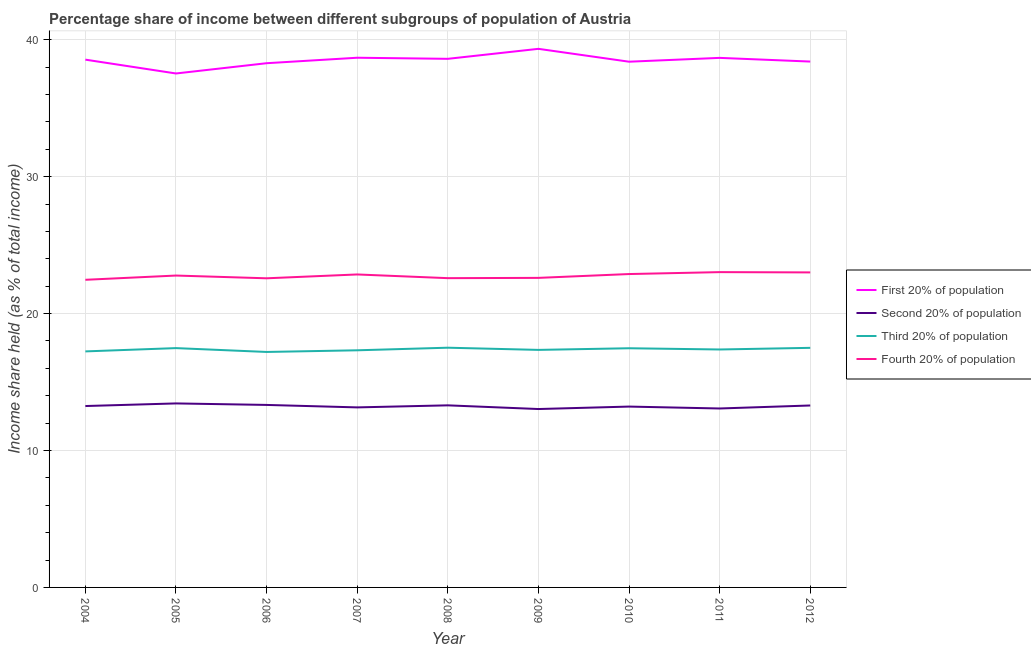Does the line corresponding to share of the income held by fourth 20% of the population intersect with the line corresponding to share of the income held by second 20% of the population?
Offer a very short reply. No. Is the number of lines equal to the number of legend labels?
Offer a very short reply. Yes. What is the share of the income held by first 20% of the population in 2011?
Your response must be concise. 38.68. Across all years, what is the maximum share of the income held by first 20% of the population?
Offer a very short reply. 39.34. In which year was the share of the income held by third 20% of the population maximum?
Offer a terse response. 2008. What is the total share of the income held by fourth 20% of the population in the graph?
Make the answer very short. 204.82. What is the difference between the share of the income held by fourth 20% of the population in 2007 and that in 2008?
Your answer should be compact. 0.27. What is the difference between the share of the income held by third 20% of the population in 2004 and the share of the income held by second 20% of the population in 2005?
Provide a succinct answer. 3.8. What is the average share of the income held by third 20% of the population per year?
Provide a succinct answer. 17.38. In the year 2007, what is the difference between the share of the income held by second 20% of the population and share of the income held by fourth 20% of the population?
Provide a short and direct response. -9.71. In how many years, is the share of the income held by first 20% of the population greater than 22 %?
Your response must be concise. 9. What is the ratio of the share of the income held by second 20% of the population in 2005 to that in 2007?
Keep it short and to the point. 1.02. Is the difference between the share of the income held by first 20% of the population in 2004 and 2005 greater than the difference between the share of the income held by third 20% of the population in 2004 and 2005?
Ensure brevity in your answer.  Yes. What is the difference between the highest and the second highest share of the income held by fourth 20% of the population?
Your answer should be very brief. 0.02. What is the difference between the highest and the lowest share of the income held by fourth 20% of the population?
Your answer should be compact. 0.56. Is the sum of the share of the income held by second 20% of the population in 2005 and 2008 greater than the maximum share of the income held by first 20% of the population across all years?
Offer a terse response. No. Is it the case that in every year, the sum of the share of the income held by first 20% of the population and share of the income held by second 20% of the population is greater than the sum of share of the income held by fourth 20% of the population and share of the income held by third 20% of the population?
Your response must be concise. Yes. Is it the case that in every year, the sum of the share of the income held by first 20% of the population and share of the income held by second 20% of the population is greater than the share of the income held by third 20% of the population?
Provide a short and direct response. Yes. Does the share of the income held by second 20% of the population monotonically increase over the years?
Make the answer very short. No. Is the share of the income held by second 20% of the population strictly greater than the share of the income held by third 20% of the population over the years?
Offer a terse response. No. What is the title of the graph?
Offer a terse response. Percentage share of income between different subgroups of population of Austria. Does "Quality Certification" appear as one of the legend labels in the graph?
Your answer should be compact. No. What is the label or title of the X-axis?
Make the answer very short. Year. What is the label or title of the Y-axis?
Your answer should be compact. Income share held (as % of total income). What is the Income share held (as % of total income) of First 20% of population in 2004?
Offer a very short reply. 38.55. What is the Income share held (as % of total income) of Second 20% of population in 2004?
Your answer should be compact. 13.25. What is the Income share held (as % of total income) of Third 20% of population in 2004?
Ensure brevity in your answer.  17.24. What is the Income share held (as % of total income) of Fourth 20% of population in 2004?
Offer a very short reply. 22.47. What is the Income share held (as % of total income) of First 20% of population in 2005?
Your answer should be very brief. 37.54. What is the Income share held (as % of total income) of Second 20% of population in 2005?
Your answer should be very brief. 13.44. What is the Income share held (as % of total income) of Third 20% of population in 2005?
Your answer should be very brief. 17.48. What is the Income share held (as % of total income) of Fourth 20% of population in 2005?
Offer a very short reply. 22.78. What is the Income share held (as % of total income) of First 20% of population in 2006?
Your answer should be compact. 38.29. What is the Income share held (as % of total income) in Second 20% of population in 2006?
Keep it short and to the point. 13.33. What is the Income share held (as % of total income) in Third 20% of population in 2006?
Your answer should be very brief. 17.2. What is the Income share held (as % of total income) of Fourth 20% of population in 2006?
Your response must be concise. 22.58. What is the Income share held (as % of total income) in First 20% of population in 2007?
Your answer should be very brief. 38.69. What is the Income share held (as % of total income) in Second 20% of population in 2007?
Your answer should be compact. 13.15. What is the Income share held (as % of total income) of Third 20% of population in 2007?
Give a very brief answer. 17.32. What is the Income share held (as % of total income) in Fourth 20% of population in 2007?
Provide a short and direct response. 22.86. What is the Income share held (as % of total income) of First 20% of population in 2008?
Your answer should be compact. 38.61. What is the Income share held (as % of total income) in Third 20% of population in 2008?
Your answer should be very brief. 17.51. What is the Income share held (as % of total income) in Fourth 20% of population in 2008?
Your answer should be very brief. 22.59. What is the Income share held (as % of total income) in First 20% of population in 2009?
Keep it short and to the point. 39.34. What is the Income share held (as % of total income) in Second 20% of population in 2009?
Ensure brevity in your answer.  13.03. What is the Income share held (as % of total income) of Third 20% of population in 2009?
Your response must be concise. 17.35. What is the Income share held (as % of total income) in Fourth 20% of population in 2009?
Give a very brief answer. 22.61. What is the Income share held (as % of total income) of First 20% of population in 2010?
Your answer should be compact. 38.4. What is the Income share held (as % of total income) in Second 20% of population in 2010?
Your response must be concise. 13.21. What is the Income share held (as % of total income) in Third 20% of population in 2010?
Ensure brevity in your answer.  17.47. What is the Income share held (as % of total income) in Fourth 20% of population in 2010?
Give a very brief answer. 22.89. What is the Income share held (as % of total income) in First 20% of population in 2011?
Your answer should be compact. 38.68. What is the Income share held (as % of total income) of Second 20% of population in 2011?
Your answer should be very brief. 13.07. What is the Income share held (as % of total income) in Third 20% of population in 2011?
Keep it short and to the point. 17.38. What is the Income share held (as % of total income) in Fourth 20% of population in 2011?
Your answer should be compact. 23.03. What is the Income share held (as % of total income) in First 20% of population in 2012?
Ensure brevity in your answer.  38.41. What is the Income share held (as % of total income) in Second 20% of population in 2012?
Give a very brief answer. 13.29. What is the Income share held (as % of total income) in Fourth 20% of population in 2012?
Your answer should be very brief. 23.01. Across all years, what is the maximum Income share held (as % of total income) in First 20% of population?
Ensure brevity in your answer.  39.34. Across all years, what is the maximum Income share held (as % of total income) in Second 20% of population?
Provide a succinct answer. 13.44. Across all years, what is the maximum Income share held (as % of total income) of Third 20% of population?
Provide a succinct answer. 17.51. Across all years, what is the maximum Income share held (as % of total income) in Fourth 20% of population?
Provide a short and direct response. 23.03. Across all years, what is the minimum Income share held (as % of total income) in First 20% of population?
Your answer should be compact. 37.54. Across all years, what is the minimum Income share held (as % of total income) in Second 20% of population?
Make the answer very short. 13.03. Across all years, what is the minimum Income share held (as % of total income) of Fourth 20% of population?
Your response must be concise. 22.47. What is the total Income share held (as % of total income) of First 20% of population in the graph?
Your answer should be very brief. 346.51. What is the total Income share held (as % of total income) in Second 20% of population in the graph?
Give a very brief answer. 119.07. What is the total Income share held (as % of total income) of Third 20% of population in the graph?
Provide a succinct answer. 156.45. What is the total Income share held (as % of total income) in Fourth 20% of population in the graph?
Give a very brief answer. 204.82. What is the difference between the Income share held (as % of total income) in First 20% of population in 2004 and that in 2005?
Provide a succinct answer. 1.01. What is the difference between the Income share held (as % of total income) in Second 20% of population in 2004 and that in 2005?
Give a very brief answer. -0.19. What is the difference between the Income share held (as % of total income) of Third 20% of population in 2004 and that in 2005?
Offer a terse response. -0.24. What is the difference between the Income share held (as % of total income) in Fourth 20% of population in 2004 and that in 2005?
Your answer should be compact. -0.31. What is the difference between the Income share held (as % of total income) of First 20% of population in 2004 and that in 2006?
Ensure brevity in your answer.  0.26. What is the difference between the Income share held (as % of total income) in Second 20% of population in 2004 and that in 2006?
Provide a succinct answer. -0.08. What is the difference between the Income share held (as % of total income) of Third 20% of population in 2004 and that in 2006?
Make the answer very short. 0.04. What is the difference between the Income share held (as % of total income) of Fourth 20% of population in 2004 and that in 2006?
Keep it short and to the point. -0.11. What is the difference between the Income share held (as % of total income) of First 20% of population in 2004 and that in 2007?
Your answer should be very brief. -0.14. What is the difference between the Income share held (as % of total income) in Second 20% of population in 2004 and that in 2007?
Provide a short and direct response. 0.1. What is the difference between the Income share held (as % of total income) of Third 20% of population in 2004 and that in 2007?
Keep it short and to the point. -0.08. What is the difference between the Income share held (as % of total income) of Fourth 20% of population in 2004 and that in 2007?
Keep it short and to the point. -0.39. What is the difference between the Income share held (as % of total income) of First 20% of population in 2004 and that in 2008?
Keep it short and to the point. -0.06. What is the difference between the Income share held (as % of total income) in Third 20% of population in 2004 and that in 2008?
Give a very brief answer. -0.27. What is the difference between the Income share held (as % of total income) of Fourth 20% of population in 2004 and that in 2008?
Keep it short and to the point. -0.12. What is the difference between the Income share held (as % of total income) in First 20% of population in 2004 and that in 2009?
Your response must be concise. -0.79. What is the difference between the Income share held (as % of total income) in Second 20% of population in 2004 and that in 2009?
Make the answer very short. 0.22. What is the difference between the Income share held (as % of total income) of Third 20% of population in 2004 and that in 2009?
Provide a succinct answer. -0.11. What is the difference between the Income share held (as % of total income) of Fourth 20% of population in 2004 and that in 2009?
Your answer should be compact. -0.14. What is the difference between the Income share held (as % of total income) of First 20% of population in 2004 and that in 2010?
Offer a very short reply. 0.15. What is the difference between the Income share held (as % of total income) in Third 20% of population in 2004 and that in 2010?
Your response must be concise. -0.23. What is the difference between the Income share held (as % of total income) of Fourth 20% of population in 2004 and that in 2010?
Keep it short and to the point. -0.42. What is the difference between the Income share held (as % of total income) of First 20% of population in 2004 and that in 2011?
Keep it short and to the point. -0.13. What is the difference between the Income share held (as % of total income) of Second 20% of population in 2004 and that in 2011?
Offer a terse response. 0.18. What is the difference between the Income share held (as % of total income) in Third 20% of population in 2004 and that in 2011?
Give a very brief answer. -0.14. What is the difference between the Income share held (as % of total income) of Fourth 20% of population in 2004 and that in 2011?
Keep it short and to the point. -0.56. What is the difference between the Income share held (as % of total income) of First 20% of population in 2004 and that in 2012?
Offer a very short reply. 0.14. What is the difference between the Income share held (as % of total income) in Second 20% of population in 2004 and that in 2012?
Provide a succinct answer. -0.04. What is the difference between the Income share held (as % of total income) in Third 20% of population in 2004 and that in 2012?
Give a very brief answer. -0.26. What is the difference between the Income share held (as % of total income) in Fourth 20% of population in 2004 and that in 2012?
Make the answer very short. -0.54. What is the difference between the Income share held (as % of total income) in First 20% of population in 2005 and that in 2006?
Your response must be concise. -0.75. What is the difference between the Income share held (as % of total income) in Second 20% of population in 2005 and that in 2006?
Keep it short and to the point. 0.11. What is the difference between the Income share held (as % of total income) in Third 20% of population in 2005 and that in 2006?
Offer a very short reply. 0.28. What is the difference between the Income share held (as % of total income) of First 20% of population in 2005 and that in 2007?
Keep it short and to the point. -1.15. What is the difference between the Income share held (as % of total income) of Second 20% of population in 2005 and that in 2007?
Provide a succinct answer. 0.29. What is the difference between the Income share held (as % of total income) in Third 20% of population in 2005 and that in 2007?
Your response must be concise. 0.16. What is the difference between the Income share held (as % of total income) of Fourth 20% of population in 2005 and that in 2007?
Provide a short and direct response. -0.08. What is the difference between the Income share held (as % of total income) in First 20% of population in 2005 and that in 2008?
Provide a succinct answer. -1.07. What is the difference between the Income share held (as % of total income) of Second 20% of population in 2005 and that in 2008?
Give a very brief answer. 0.14. What is the difference between the Income share held (as % of total income) of Third 20% of population in 2005 and that in 2008?
Give a very brief answer. -0.03. What is the difference between the Income share held (as % of total income) in Fourth 20% of population in 2005 and that in 2008?
Give a very brief answer. 0.19. What is the difference between the Income share held (as % of total income) in First 20% of population in 2005 and that in 2009?
Your answer should be very brief. -1.8. What is the difference between the Income share held (as % of total income) of Second 20% of population in 2005 and that in 2009?
Provide a short and direct response. 0.41. What is the difference between the Income share held (as % of total income) of Third 20% of population in 2005 and that in 2009?
Keep it short and to the point. 0.13. What is the difference between the Income share held (as % of total income) in Fourth 20% of population in 2005 and that in 2009?
Keep it short and to the point. 0.17. What is the difference between the Income share held (as % of total income) of First 20% of population in 2005 and that in 2010?
Your answer should be very brief. -0.86. What is the difference between the Income share held (as % of total income) in Second 20% of population in 2005 and that in 2010?
Keep it short and to the point. 0.23. What is the difference between the Income share held (as % of total income) in Third 20% of population in 2005 and that in 2010?
Keep it short and to the point. 0.01. What is the difference between the Income share held (as % of total income) of Fourth 20% of population in 2005 and that in 2010?
Provide a succinct answer. -0.11. What is the difference between the Income share held (as % of total income) of First 20% of population in 2005 and that in 2011?
Your answer should be very brief. -1.14. What is the difference between the Income share held (as % of total income) of Second 20% of population in 2005 and that in 2011?
Provide a succinct answer. 0.37. What is the difference between the Income share held (as % of total income) of First 20% of population in 2005 and that in 2012?
Provide a succinct answer. -0.87. What is the difference between the Income share held (as % of total income) of Second 20% of population in 2005 and that in 2012?
Keep it short and to the point. 0.15. What is the difference between the Income share held (as % of total income) in Third 20% of population in 2005 and that in 2012?
Your response must be concise. -0.02. What is the difference between the Income share held (as % of total income) in Fourth 20% of population in 2005 and that in 2012?
Offer a terse response. -0.23. What is the difference between the Income share held (as % of total income) of Second 20% of population in 2006 and that in 2007?
Provide a short and direct response. 0.18. What is the difference between the Income share held (as % of total income) in Third 20% of population in 2006 and that in 2007?
Provide a succinct answer. -0.12. What is the difference between the Income share held (as % of total income) of Fourth 20% of population in 2006 and that in 2007?
Make the answer very short. -0.28. What is the difference between the Income share held (as % of total income) of First 20% of population in 2006 and that in 2008?
Your answer should be very brief. -0.32. What is the difference between the Income share held (as % of total income) in Third 20% of population in 2006 and that in 2008?
Provide a succinct answer. -0.31. What is the difference between the Income share held (as % of total income) in Fourth 20% of population in 2006 and that in 2008?
Keep it short and to the point. -0.01. What is the difference between the Income share held (as % of total income) of First 20% of population in 2006 and that in 2009?
Your response must be concise. -1.05. What is the difference between the Income share held (as % of total income) in Third 20% of population in 2006 and that in 2009?
Ensure brevity in your answer.  -0.15. What is the difference between the Income share held (as % of total income) in Fourth 20% of population in 2006 and that in 2009?
Provide a short and direct response. -0.03. What is the difference between the Income share held (as % of total income) of First 20% of population in 2006 and that in 2010?
Offer a very short reply. -0.11. What is the difference between the Income share held (as % of total income) of Second 20% of population in 2006 and that in 2010?
Give a very brief answer. 0.12. What is the difference between the Income share held (as % of total income) of Third 20% of population in 2006 and that in 2010?
Provide a succinct answer. -0.27. What is the difference between the Income share held (as % of total income) of Fourth 20% of population in 2006 and that in 2010?
Make the answer very short. -0.31. What is the difference between the Income share held (as % of total income) of First 20% of population in 2006 and that in 2011?
Keep it short and to the point. -0.39. What is the difference between the Income share held (as % of total income) in Second 20% of population in 2006 and that in 2011?
Offer a terse response. 0.26. What is the difference between the Income share held (as % of total income) in Third 20% of population in 2006 and that in 2011?
Offer a very short reply. -0.18. What is the difference between the Income share held (as % of total income) of Fourth 20% of population in 2006 and that in 2011?
Your answer should be very brief. -0.45. What is the difference between the Income share held (as % of total income) in First 20% of population in 2006 and that in 2012?
Your answer should be compact. -0.12. What is the difference between the Income share held (as % of total income) in Second 20% of population in 2006 and that in 2012?
Offer a very short reply. 0.04. What is the difference between the Income share held (as % of total income) of Fourth 20% of population in 2006 and that in 2012?
Make the answer very short. -0.43. What is the difference between the Income share held (as % of total income) in First 20% of population in 2007 and that in 2008?
Provide a succinct answer. 0.08. What is the difference between the Income share held (as % of total income) in Third 20% of population in 2007 and that in 2008?
Your answer should be very brief. -0.19. What is the difference between the Income share held (as % of total income) of Fourth 20% of population in 2007 and that in 2008?
Your answer should be very brief. 0.27. What is the difference between the Income share held (as % of total income) in First 20% of population in 2007 and that in 2009?
Keep it short and to the point. -0.65. What is the difference between the Income share held (as % of total income) in Second 20% of population in 2007 and that in 2009?
Provide a short and direct response. 0.12. What is the difference between the Income share held (as % of total income) in Third 20% of population in 2007 and that in 2009?
Ensure brevity in your answer.  -0.03. What is the difference between the Income share held (as % of total income) of Fourth 20% of population in 2007 and that in 2009?
Your answer should be very brief. 0.25. What is the difference between the Income share held (as % of total income) of First 20% of population in 2007 and that in 2010?
Make the answer very short. 0.29. What is the difference between the Income share held (as % of total income) of Second 20% of population in 2007 and that in 2010?
Your response must be concise. -0.06. What is the difference between the Income share held (as % of total income) of Fourth 20% of population in 2007 and that in 2010?
Make the answer very short. -0.03. What is the difference between the Income share held (as % of total income) in First 20% of population in 2007 and that in 2011?
Your answer should be compact. 0.01. What is the difference between the Income share held (as % of total income) in Second 20% of population in 2007 and that in 2011?
Your answer should be very brief. 0.08. What is the difference between the Income share held (as % of total income) in Third 20% of population in 2007 and that in 2011?
Your answer should be very brief. -0.06. What is the difference between the Income share held (as % of total income) in Fourth 20% of population in 2007 and that in 2011?
Offer a terse response. -0.17. What is the difference between the Income share held (as % of total income) of First 20% of population in 2007 and that in 2012?
Your answer should be very brief. 0.28. What is the difference between the Income share held (as % of total income) in Second 20% of population in 2007 and that in 2012?
Your response must be concise. -0.14. What is the difference between the Income share held (as % of total income) in Third 20% of population in 2007 and that in 2012?
Your answer should be very brief. -0.18. What is the difference between the Income share held (as % of total income) of Fourth 20% of population in 2007 and that in 2012?
Give a very brief answer. -0.15. What is the difference between the Income share held (as % of total income) in First 20% of population in 2008 and that in 2009?
Provide a short and direct response. -0.73. What is the difference between the Income share held (as % of total income) of Second 20% of population in 2008 and that in 2009?
Ensure brevity in your answer.  0.27. What is the difference between the Income share held (as % of total income) of Third 20% of population in 2008 and that in 2009?
Make the answer very short. 0.16. What is the difference between the Income share held (as % of total income) in Fourth 20% of population in 2008 and that in 2009?
Keep it short and to the point. -0.02. What is the difference between the Income share held (as % of total income) in First 20% of population in 2008 and that in 2010?
Keep it short and to the point. 0.21. What is the difference between the Income share held (as % of total income) of Second 20% of population in 2008 and that in 2010?
Provide a short and direct response. 0.09. What is the difference between the Income share held (as % of total income) in Third 20% of population in 2008 and that in 2010?
Ensure brevity in your answer.  0.04. What is the difference between the Income share held (as % of total income) of First 20% of population in 2008 and that in 2011?
Provide a short and direct response. -0.07. What is the difference between the Income share held (as % of total income) in Second 20% of population in 2008 and that in 2011?
Offer a terse response. 0.23. What is the difference between the Income share held (as % of total income) of Third 20% of population in 2008 and that in 2011?
Provide a short and direct response. 0.13. What is the difference between the Income share held (as % of total income) of Fourth 20% of population in 2008 and that in 2011?
Keep it short and to the point. -0.44. What is the difference between the Income share held (as % of total income) of First 20% of population in 2008 and that in 2012?
Ensure brevity in your answer.  0.2. What is the difference between the Income share held (as % of total income) in Second 20% of population in 2008 and that in 2012?
Your answer should be compact. 0.01. What is the difference between the Income share held (as % of total income) in Fourth 20% of population in 2008 and that in 2012?
Your answer should be compact. -0.42. What is the difference between the Income share held (as % of total income) in First 20% of population in 2009 and that in 2010?
Provide a succinct answer. 0.94. What is the difference between the Income share held (as % of total income) in Second 20% of population in 2009 and that in 2010?
Your answer should be compact. -0.18. What is the difference between the Income share held (as % of total income) in Third 20% of population in 2009 and that in 2010?
Keep it short and to the point. -0.12. What is the difference between the Income share held (as % of total income) in Fourth 20% of population in 2009 and that in 2010?
Provide a succinct answer. -0.28. What is the difference between the Income share held (as % of total income) of First 20% of population in 2009 and that in 2011?
Your response must be concise. 0.66. What is the difference between the Income share held (as % of total income) in Second 20% of population in 2009 and that in 2011?
Your answer should be compact. -0.04. What is the difference between the Income share held (as % of total income) of Third 20% of population in 2009 and that in 2011?
Make the answer very short. -0.03. What is the difference between the Income share held (as % of total income) in Fourth 20% of population in 2009 and that in 2011?
Provide a succinct answer. -0.42. What is the difference between the Income share held (as % of total income) in Second 20% of population in 2009 and that in 2012?
Your response must be concise. -0.26. What is the difference between the Income share held (as % of total income) in First 20% of population in 2010 and that in 2011?
Your answer should be compact. -0.28. What is the difference between the Income share held (as % of total income) of Second 20% of population in 2010 and that in 2011?
Make the answer very short. 0.14. What is the difference between the Income share held (as % of total income) of Third 20% of population in 2010 and that in 2011?
Your answer should be very brief. 0.09. What is the difference between the Income share held (as % of total income) of Fourth 20% of population in 2010 and that in 2011?
Your answer should be very brief. -0.14. What is the difference between the Income share held (as % of total income) in First 20% of population in 2010 and that in 2012?
Offer a very short reply. -0.01. What is the difference between the Income share held (as % of total income) in Second 20% of population in 2010 and that in 2012?
Give a very brief answer. -0.08. What is the difference between the Income share held (as % of total income) in Third 20% of population in 2010 and that in 2012?
Keep it short and to the point. -0.03. What is the difference between the Income share held (as % of total income) in Fourth 20% of population in 2010 and that in 2012?
Your answer should be compact. -0.12. What is the difference between the Income share held (as % of total income) of First 20% of population in 2011 and that in 2012?
Provide a short and direct response. 0.27. What is the difference between the Income share held (as % of total income) of Second 20% of population in 2011 and that in 2012?
Your answer should be compact. -0.22. What is the difference between the Income share held (as % of total income) in Third 20% of population in 2011 and that in 2012?
Keep it short and to the point. -0.12. What is the difference between the Income share held (as % of total income) of First 20% of population in 2004 and the Income share held (as % of total income) of Second 20% of population in 2005?
Ensure brevity in your answer.  25.11. What is the difference between the Income share held (as % of total income) of First 20% of population in 2004 and the Income share held (as % of total income) of Third 20% of population in 2005?
Provide a short and direct response. 21.07. What is the difference between the Income share held (as % of total income) in First 20% of population in 2004 and the Income share held (as % of total income) in Fourth 20% of population in 2005?
Your answer should be very brief. 15.77. What is the difference between the Income share held (as % of total income) in Second 20% of population in 2004 and the Income share held (as % of total income) in Third 20% of population in 2005?
Ensure brevity in your answer.  -4.23. What is the difference between the Income share held (as % of total income) in Second 20% of population in 2004 and the Income share held (as % of total income) in Fourth 20% of population in 2005?
Provide a succinct answer. -9.53. What is the difference between the Income share held (as % of total income) of Third 20% of population in 2004 and the Income share held (as % of total income) of Fourth 20% of population in 2005?
Ensure brevity in your answer.  -5.54. What is the difference between the Income share held (as % of total income) of First 20% of population in 2004 and the Income share held (as % of total income) of Second 20% of population in 2006?
Your response must be concise. 25.22. What is the difference between the Income share held (as % of total income) in First 20% of population in 2004 and the Income share held (as % of total income) in Third 20% of population in 2006?
Your response must be concise. 21.35. What is the difference between the Income share held (as % of total income) in First 20% of population in 2004 and the Income share held (as % of total income) in Fourth 20% of population in 2006?
Your response must be concise. 15.97. What is the difference between the Income share held (as % of total income) in Second 20% of population in 2004 and the Income share held (as % of total income) in Third 20% of population in 2006?
Keep it short and to the point. -3.95. What is the difference between the Income share held (as % of total income) of Second 20% of population in 2004 and the Income share held (as % of total income) of Fourth 20% of population in 2006?
Your answer should be compact. -9.33. What is the difference between the Income share held (as % of total income) in Third 20% of population in 2004 and the Income share held (as % of total income) in Fourth 20% of population in 2006?
Your answer should be very brief. -5.34. What is the difference between the Income share held (as % of total income) of First 20% of population in 2004 and the Income share held (as % of total income) of Second 20% of population in 2007?
Your response must be concise. 25.4. What is the difference between the Income share held (as % of total income) of First 20% of population in 2004 and the Income share held (as % of total income) of Third 20% of population in 2007?
Your answer should be very brief. 21.23. What is the difference between the Income share held (as % of total income) in First 20% of population in 2004 and the Income share held (as % of total income) in Fourth 20% of population in 2007?
Offer a terse response. 15.69. What is the difference between the Income share held (as % of total income) of Second 20% of population in 2004 and the Income share held (as % of total income) of Third 20% of population in 2007?
Your answer should be very brief. -4.07. What is the difference between the Income share held (as % of total income) in Second 20% of population in 2004 and the Income share held (as % of total income) in Fourth 20% of population in 2007?
Give a very brief answer. -9.61. What is the difference between the Income share held (as % of total income) of Third 20% of population in 2004 and the Income share held (as % of total income) of Fourth 20% of population in 2007?
Ensure brevity in your answer.  -5.62. What is the difference between the Income share held (as % of total income) of First 20% of population in 2004 and the Income share held (as % of total income) of Second 20% of population in 2008?
Make the answer very short. 25.25. What is the difference between the Income share held (as % of total income) of First 20% of population in 2004 and the Income share held (as % of total income) of Third 20% of population in 2008?
Your answer should be very brief. 21.04. What is the difference between the Income share held (as % of total income) in First 20% of population in 2004 and the Income share held (as % of total income) in Fourth 20% of population in 2008?
Your response must be concise. 15.96. What is the difference between the Income share held (as % of total income) of Second 20% of population in 2004 and the Income share held (as % of total income) of Third 20% of population in 2008?
Make the answer very short. -4.26. What is the difference between the Income share held (as % of total income) in Second 20% of population in 2004 and the Income share held (as % of total income) in Fourth 20% of population in 2008?
Your answer should be very brief. -9.34. What is the difference between the Income share held (as % of total income) in Third 20% of population in 2004 and the Income share held (as % of total income) in Fourth 20% of population in 2008?
Offer a very short reply. -5.35. What is the difference between the Income share held (as % of total income) of First 20% of population in 2004 and the Income share held (as % of total income) of Second 20% of population in 2009?
Your response must be concise. 25.52. What is the difference between the Income share held (as % of total income) of First 20% of population in 2004 and the Income share held (as % of total income) of Third 20% of population in 2009?
Offer a very short reply. 21.2. What is the difference between the Income share held (as % of total income) in First 20% of population in 2004 and the Income share held (as % of total income) in Fourth 20% of population in 2009?
Your answer should be compact. 15.94. What is the difference between the Income share held (as % of total income) in Second 20% of population in 2004 and the Income share held (as % of total income) in Fourth 20% of population in 2009?
Your response must be concise. -9.36. What is the difference between the Income share held (as % of total income) in Third 20% of population in 2004 and the Income share held (as % of total income) in Fourth 20% of population in 2009?
Offer a very short reply. -5.37. What is the difference between the Income share held (as % of total income) in First 20% of population in 2004 and the Income share held (as % of total income) in Second 20% of population in 2010?
Your answer should be compact. 25.34. What is the difference between the Income share held (as % of total income) of First 20% of population in 2004 and the Income share held (as % of total income) of Third 20% of population in 2010?
Offer a terse response. 21.08. What is the difference between the Income share held (as % of total income) of First 20% of population in 2004 and the Income share held (as % of total income) of Fourth 20% of population in 2010?
Provide a short and direct response. 15.66. What is the difference between the Income share held (as % of total income) of Second 20% of population in 2004 and the Income share held (as % of total income) of Third 20% of population in 2010?
Your answer should be very brief. -4.22. What is the difference between the Income share held (as % of total income) of Second 20% of population in 2004 and the Income share held (as % of total income) of Fourth 20% of population in 2010?
Provide a short and direct response. -9.64. What is the difference between the Income share held (as % of total income) of Third 20% of population in 2004 and the Income share held (as % of total income) of Fourth 20% of population in 2010?
Offer a very short reply. -5.65. What is the difference between the Income share held (as % of total income) in First 20% of population in 2004 and the Income share held (as % of total income) in Second 20% of population in 2011?
Provide a succinct answer. 25.48. What is the difference between the Income share held (as % of total income) in First 20% of population in 2004 and the Income share held (as % of total income) in Third 20% of population in 2011?
Keep it short and to the point. 21.17. What is the difference between the Income share held (as % of total income) in First 20% of population in 2004 and the Income share held (as % of total income) in Fourth 20% of population in 2011?
Your answer should be compact. 15.52. What is the difference between the Income share held (as % of total income) in Second 20% of population in 2004 and the Income share held (as % of total income) in Third 20% of population in 2011?
Your response must be concise. -4.13. What is the difference between the Income share held (as % of total income) of Second 20% of population in 2004 and the Income share held (as % of total income) of Fourth 20% of population in 2011?
Keep it short and to the point. -9.78. What is the difference between the Income share held (as % of total income) of Third 20% of population in 2004 and the Income share held (as % of total income) of Fourth 20% of population in 2011?
Offer a terse response. -5.79. What is the difference between the Income share held (as % of total income) in First 20% of population in 2004 and the Income share held (as % of total income) in Second 20% of population in 2012?
Your response must be concise. 25.26. What is the difference between the Income share held (as % of total income) in First 20% of population in 2004 and the Income share held (as % of total income) in Third 20% of population in 2012?
Offer a terse response. 21.05. What is the difference between the Income share held (as % of total income) in First 20% of population in 2004 and the Income share held (as % of total income) in Fourth 20% of population in 2012?
Your answer should be compact. 15.54. What is the difference between the Income share held (as % of total income) in Second 20% of population in 2004 and the Income share held (as % of total income) in Third 20% of population in 2012?
Offer a terse response. -4.25. What is the difference between the Income share held (as % of total income) of Second 20% of population in 2004 and the Income share held (as % of total income) of Fourth 20% of population in 2012?
Offer a terse response. -9.76. What is the difference between the Income share held (as % of total income) in Third 20% of population in 2004 and the Income share held (as % of total income) in Fourth 20% of population in 2012?
Provide a succinct answer. -5.77. What is the difference between the Income share held (as % of total income) in First 20% of population in 2005 and the Income share held (as % of total income) in Second 20% of population in 2006?
Make the answer very short. 24.21. What is the difference between the Income share held (as % of total income) of First 20% of population in 2005 and the Income share held (as % of total income) of Third 20% of population in 2006?
Offer a very short reply. 20.34. What is the difference between the Income share held (as % of total income) of First 20% of population in 2005 and the Income share held (as % of total income) of Fourth 20% of population in 2006?
Your response must be concise. 14.96. What is the difference between the Income share held (as % of total income) of Second 20% of population in 2005 and the Income share held (as % of total income) of Third 20% of population in 2006?
Your answer should be compact. -3.76. What is the difference between the Income share held (as % of total income) of Second 20% of population in 2005 and the Income share held (as % of total income) of Fourth 20% of population in 2006?
Ensure brevity in your answer.  -9.14. What is the difference between the Income share held (as % of total income) in Third 20% of population in 2005 and the Income share held (as % of total income) in Fourth 20% of population in 2006?
Provide a succinct answer. -5.1. What is the difference between the Income share held (as % of total income) in First 20% of population in 2005 and the Income share held (as % of total income) in Second 20% of population in 2007?
Give a very brief answer. 24.39. What is the difference between the Income share held (as % of total income) in First 20% of population in 2005 and the Income share held (as % of total income) in Third 20% of population in 2007?
Offer a very short reply. 20.22. What is the difference between the Income share held (as % of total income) of First 20% of population in 2005 and the Income share held (as % of total income) of Fourth 20% of population in 2007?
Keep it short and to the point. 14.68. What is the difference between the Income share held (as % of total income) of Second 20% of population in 2005 and the Income share held (as % of total income) of Third 20% of population in 2007?
Ensure brevity in your answer.  -3.88. What is the difference between the Income share held (as % of total income) in Second 20% of population in 2005 and the Income share held (as % of total income) in Fourth 20% of population in 2007?
Offer a terse response. -9.42. What is the difference between the Income share held (as % of total income) in Third 20% of population in 2005 and the Income share held (as % of total income) in Fourth 20% of population in 2007?
Keep it short and to the point. -5.38. What is the difference between the Income share held (as % of total income) of First 20% of population in 2005 and the Income share held (as % of total income) of Second 20% of population in 2008?
Ensure brevity in your answer.  24.24. What is the difference between the Income share held (as % of total income) of First 20% of population in 2005 and the Income share held (as % of total income) of Third 20% of population in 2008?
Give a very brief answer. 20.03. What is the difference between the Income share held (as % of total income) of First 20% of population in 2005 and the Income share held (as % of total income) of Fourth 20% of population in 2008?
Provide a succinct answer. 14.95. What is the difference between the Income share held (as % of total income) in Second 20% of population in 2005 and the Income share held (as % of total income) in Third 20% of population in 2008?
Offer a very short reply. -4.07. What is the difference between the Income share held (as % of total income) in Second 20% of population in 2005 and the Income share held (as % of total income) in Fourth 20% of population in 2008?
Your answer should be compact. -9.15. What is the difference between the Income share held (as % of total income) in Third 20% of population in 2005 and the Income share held (as % of total income) in Fourth 20% of population in 2008?
Provide a succinct answer. -5.11. What is the difference between the Income share held (as % of total income) of First 20% of population in 2005 and the Income share held (as % of total income) of Second 20% of population in 2009?
Make the answer very short. 24.51. What is the difference between the Income share held (as % of total income) of First 20% of population in 2005 and the Income share held (as % of total income) of Third 20% of population in 2009?
Ensure brevity in your answer.  20.19. What is the difference between the Income share held (as % of total income) in First 20% of population in 2005 and the Income share held (as % of total income) in Fourth 20% of population in 2009?
Make the answer very short. 14.93. What is the difference between the Income share held (as % of total income) in Second 20% of population in 2005 and the Income share held (as % of total income) in Third 20% of population in 2009?
Your response must be concise. -3.91. What is the difference between the Income share held (as % of total income) in Second 20% of population in 2005 and the Income share held (as % of total income) in Fourth 20% of population in 2009?
Offer a terse response. -9.17. What is the difference between the Income share held (as % of total income) of Third 20% of population in 2005 and the Income share held (as % of total income) of Fourth 20% of population in 2009?
Provide a succinct answer. -5.13. What is the difference between the Income share held (as % of total income) of First 20% of population in 2005 and the Income share held (as % of total income) of Second 20% of population in 2010?
Offer a very short reply. 24.33. What is the difference between the Income share held (as % of total income) in First 20% of population in 2005 and the Income share held (as % of total income) in Third 20% of population in 2010?
Provide a succinct answer. 20.07. What is the difference between the Income share held (as % of total income) of First 20% of population in 2005 and the Income share held (as % of total income) of Fourth 20% of population in 2010?
Keep it short and to the point. 14.65. What is the difference between the Income share held (as % of total income) in Second 20% of population in 2005 and the Income share held (as % of total income) in Third 20% of population in 2010?
Provide a succinct answer. -4.03. What is the difference between the Income share held (as % of total income) in Second 20% of population in 2005 and the Income share held (as % of total income) in Fourth 20% of population in 2010?
Provide a succinct answer. -9.45. What is the difference between the Income share held (as % of total income) of Third 20% of population in 2005 and the Income share held (as % of total income) of Fourth 20% of population in 2010?
Keep it short and to the point. -5.41. What is the difference between the Income share held (as % of total income) of First 20% of population in 2005 and the Income share held (as % of total income) of Second 20% of population in 2011?
Keep it short and to the point. 24.47. What is the difference between the Income share held (as % of total income) of First 20% of population in 2005 and the Income share held (as % of total income) of Third 20% of population in 2011?
Offer a very short reply. 20.16. What is the difference between the Income share held (as % of total income) in First 20% of population in 2005 and the Income share held (as % of total income) in Fourth 20% of population in 2011?
Make the answer very short. 14.51. What is the difference between the Income share held (as % of total income) of Second 20% of population in 2005 and the Income share held (as % of total income) of Third 20% of population in 2011?
Give a very brief answer. -3.94. What is the difference between the Income share held (as % of total income) in Second 20% of population in 2005 and the Income share held (as % of total income) in Fourth 20% of population in 2011?
Your answer should be very brief. -9.59. What is the difference between the Income share held (as % of total income) of Third 20% of population in 2005 and the Income share held (as % of total income) of Fourth 20% of population in 2011?
Ensure brevity in your answer.  -5.55. What is the difference between the Income share held (as % of total income) of First 20% of population in 2005 and the Income share held (as % of total income) of Second 20% of population in 2012?
Keep it short and to the point. 24.25. What is the difference between the Income share held (as % of total income) of First 20% of population in 2005 and the Income share held (as % of total income) of Third 20% of population in 2012?
Your answer should be compact. 20.04. What is the difference between the Income share held (as % of total income) in First 20% of population in 2005 and the Income share held (as % of total income) in Fourth 20% of population in 2012?
Provide a succinct answer. 14.53. What is the difference between the Income share held (as % of total income) in Second 20% of population in 2005 and the Income share held (as % of total income) in Third 20% of population in 2012?
Your answer should be very brief. -4.06. What is the difference between the Income share held (as % of total income) of Second 20% of population in 2005 and the Income share held (as % of total income) of Fourth 20% of population in 2012?
Provide a succinct answer. -9.57. What is the difference between the Income share held (as % of total income) of Third 20% of population in 2005 and the Income share held (as % of total income) of Fourth 20% of population in 2012?
Your answer should be compact. -5.53. What is the difference between the Income share held (as % of total income) in First 20% of population in 2006 and the Income share held (as % of total income) in Second 20% of population in 2007?
Your answer should be very brief. 25.14. What is the difference between the Income share held (as % of total income) in First 20% of population in 2006 and the Income share held (as % of total income) in Third 20% of population in 2007?
Give a very brief answer. 20.97. What is the difference between the Income share held (as % of total income) in First 20% of population in 2006 and the Income share held (as % of total income) in Fourth 20% of population in 2007?
Your response must be concise. 15.43. What is the difference between the Income share held (as % of total income) of Second 20% of population in 2006 and the Income share held (as % of total income) of Third 20% of population in 2007?
Your answer should be compact. -3.99. What is the difference between the Income share held (as % of total income) in Second 20% of population in 2006 and the Income share held (as % of total income) in Fourth 20% of population in 2007?
Give a very brief answer. -9.53. What is the difference between the Income share held (as % of total income) in Third 20% of population in 2006 and the Income share held (as % of total income) in Fourth 20% of population in 2007?
Your answer should be compact. -5.66. What is the difference between the Income share held (as % of total income) of First 20% of population in 2006 and the Income share held (as % of total income) of Second 20% of population in 2008?
Your response must be concise. 24.99. What is the difference between the Income share held (as % of total income) of First 20% of population in 2006 and the Income share held (as % of total income) of Third 20% of population in 2008?
Your answer should be very brief. 20.78. What is the difference between the Income share held (as % of total income) in First 20% of population in 2006 and the Income share held (as % of total income) in Fourth 20% of population in 2008?
Make the answer very short. 15.7. What is the difference between the Income share held (as % of total income) in Second 20% of population in 2006 and the Income share held (as % of total income) in Third 20% of population in 2008?
Ensure brevity in your answer.  -4.18. What is the difference between the Income share held (as % of total income) in Second 20% of population in 2006 and the Income share held (as % of total income) in Fourth 20% of population in 2008?
Your answer should be compact. -9.26. What is the difference between the Income share held (as % of total income) in Third 20% of population in 2006 and the Income share held (as % of total income) in Fourth 20% of population in 2008?
Give a very brief answer. -5.39. What is the difference between the Income share held (as % of total income) in First 20% of population in 2006 and the Income share held (as % of total income) in Second 20% of population in 2009?
Keep it short and to the point. 25.26. What is the difference between the Income share held (as % of total income) of First 20% of population in 2006 and the Income share held (as % of total income) of Third 20% of population in 2009?
Your response must be concise. 20.94. What is the difference between the Income share held (as % of total income) in First 20% of population in 2006 and the Income share held (as % of total income) in Fourth 20% of population in 2009?
Your answer should be compact. 15.68. What is the difference between the Income share held (as % of total income) in Second 20% of population in 2006 and the Income share held (as % of total income) in Third 20% of population in 2009?
Your response must be concise. -4.02. What is the difference between the Income share held (as % of total income) of Second 20% of population in 2006 and the Income share held (as % of total income) of Fourth 20% of population in 2009?
Offer a terse response. -9.28. What is the difference between the Income share held (as % of total income) of Third 20% of population in 2006 and the Income share held (as % of total income) of Fourth 20% of population in 2009?
Your answer should be very brief. -5.41. What is the difference between the Income share held (as % of total income) of First 20% of population in 2006 and the Income share held (as % of total income) of Second 20% of population in 2010?
Ensure brevity in your answer.  25.08. What is the difference between the Income share held (as % of total income) in First 20% of population in 2006 and the Income share held (as % of total income) in Third 20% of population in 2010?
Your answer should be compact. 20.82. What is the difference between the Income share held (as % of total income) of First 20% of population in 2006 and the Income share held (as % of total income) of Fourth 20% of population in 2010?
Keep it short and to the point. 15.4. What is the difference between the Income share held (as % of total income) of Second 20% of population in 2006 and the Income share held (as % of total income) of Third 20% of population in 2010?
Offer a terse response. -4.14. What is the difference between the Income share held (as % of total income) in Second 20% of population in 2006 and the Income share held (as % of total income) in Fourth 20% of population in 2010?
Keep it short and to the point. -9.56. What is the difference between the Income share held (as % of total income) of Third 20% of population in 2006 and the Income share held (as % of total income) of Fourth 20% of population in 2010?
Ensure brevity in your answer.  -5.69. What is the difference between the Income share held (as % of total income) in First 20% of population in 2006 and the Income share held (as % of total income) in Second 20% of population in 2011?
Your response must be concise. 25.22. What is the difference between the Income share held (as % of total income) in First 20% of population in 2006 and the Income share held (as % of total income) in Third 20% of population in 2011?
Your answer should be very brief. 20.91. What is the difference between the Income share held (as % of total income) in First 20% of population in 2006 and the Income share held (as % of total income) in Fourth 20% of population in 2011?
Make the answer very short. 15.26. What is the difference between the Income share held (as % of total income) of Second 20% of population in 2006 and the Income share held (as % of total income) of Third 20% of population in 2011?
Make the answer very short. -4.05. What is the difference between the Income share held (as % of total income) in Second 20% of population in 2006 and the Income share held (as % of total income) in Fourth 20% of population in 2011?
Offer a terse response. -9.7. What is the difference between the Income share held (as % of total income) in Third 20% of population in 2006 and the Income share held (as % of total income) in Fourth 20% of population in 2011?
Your answer should be very brief. -5.83. What is the difference between the Income share held (as % of total income) of First 20% of population in 2006 and the Income share held (as % of total income) of Third 20% of population in 2012?
Your answer should be compact. 20.79. What is the difference between the Income share held (as % of total income) in First 20% of population in 2006 and the Income share held (as % of total income) in Fourth 20% of population in 2012?
Ensure brevity in your answer.  15.28. What is the difference between the Income share held (as % of total income) in Second 20% of population in 2006 and the Income share held (as % of total income) in Third 20% of population in 2012?
Offer a very short reply. -4.17. What is the difference between the Income share held (as % of total income) of Second 20% of population in 2006 and the Income share held (as % of total income) of Fourth 20% of population in 2012?
Your answer should be compact. -9.68. What is the difference between the Income share held (as % of total income) of Third 20% of population in 2006 and the Income share held (as % of total income) of Fourth 20% of population in 2012?
Your answer should be compact. -5.81. What is the difference between the Income share held (as % of total income) in First 20% of population in 2007 and the Income share held (as % of total income) in Second 20% of population in 2008?
Ensure brevity in your answer.  25.39. What is the difference between the Income share held (as % of total income) in First 20% of population in 2007 and the Income share held (as % of total income) in Third 20% of population in 2008?
Provide a succinct answer. 21.18. What is the difference between the Income share held (as % of total income) in Second 20% of population in 2007 and the Income share held (as % of total income) in Third 20% of population in 2008?
Keep it short and to the point. -4.36. What is the difference between the Income share held (as % of total income) of Second 20% of population in 2007 and the Income share held (as % of total income) of Fourth 20% of population in 2008?
Keep it short and to the point. -9.44. What is the difference between the Income share held (as % of total income) of Third 20% of population in 2007 and the Income share held (as % of total income) of Fourth 20% of population in 2008?
Give a very brief answer. -5.27. What is the difference between the Income share held (as % of total income) of First 20% of population in 2007 and the Income share held (as % of total income) of Second 20% of population in 2009?
Provide a succinct answer. 25.66. What is the difference between the Income share held (as % of total income) of First 20% of population in 2007 and the Income share held (as % of total income) of Third 20% of population in 2009?
Give a very brief answer. 21.34. What is the difference between the Income share held (as % of total income) of First 20% of population in 2007 and the Income share held (as % of total income) of Fourth 20% of population in 2009?
Provide a short and direct response. 16.08. What is the difference between the Income share held (as % of total income) of Second 20% of population in 2007 and the Income share held (as % of total income) of Fourth 20% of population in 2009?
Offer a terse response. -9.46. What is the difference between the Income share held (as % of total income) in Third 20% of population in 2007 and the Income share held (as % of total income) in Fourth 20% of population in 2009?
Give a very brief answer. -5.29. What is the difference between the Income share held (as % of total income) of First 20% of population in 2007 and the Income share held (as % of total income) of Second 20% of population in 2010?
Provide a short and direct response. 25.48. What is the difference between the Income share held (as % of total income) in First 20% of population in 2007 and the Income share held (as % of total income) in Third 20% of population in 2010?
Provide a short and direct response. 21.22. What is the difference between the Income share held (as % of total income) of Second 20% of population in 2007 and the Income share held (as % of total income) of Third 20% of population in 2010?
Make the answer very short. -4.32. What is the difference between the Income share held (as % of total income) of Second 20% of population in 2007 and the Income share held (as % of total income) of Fourth 20% of population in 2010?
Offer a terse response. -9.74. What is the difference between the Income share held (as % of total income) in Third 20% of population in 2007 and the Income share held (as % of total income) in Fourth 20% of population in 2010?
Offer a very short reply. -5.57. What is the difference between the Income share held (as % of total income) in First 20% of population in 2007 and the Income share held (as % of total income) in Second 20% of population in 2011?
Give a very brief answer. 25.62. What is the difference between the Income share held (as % of total income) of First 20% of population in 2007 and the Income share held (as % of total income) of Third 20% of population in 2011?
Your answer should be compact. 21.31. What is the difference between the Income share held (as % of total income) of First 20% of population in 2007 and the Income share held (as % of total income) of Fourth 20% of population in 2011?
Your answer should be very brief. 15.66. What is the difference between the Income share held (as % of total income) in Second 20% of population in 2007 and the Income share held (as % of total income) in Third 20% of population in 2011?
Offer a very short reply. -4.23. What is the difference between the Income share held (as % of total income) in Second 20% of population in 2007 and the Income share held (as % of total income) in Fourth 20% of population in 2011?
Your answer should be very brief. -9.88. What is the difference between the Income share held (as % of total income) of Third 20% of population in 2007 and the Income share held (as % of total income) of Fourth 20% of population in 2011?
Your response must be concise. -5.71. What is the difference between the Income share held (as % of total income) in First 20% of population in 2007 and the Income share held (as % of total income) in Second 20% of population in 2012?
Provide a succinct answer. 25.4. What is the difference between the Income share held (as % of total income) of First 20% of population in 2007 and the Income share held (as % of total income) of Third 20% of population in 2012?
Your answer should be very brief. 21.19. What is the difference between the Income share held (as % of total income) of First 20% of population in 2007 and the Income share held (as % of total income) of Fourth 20% of population in 2012?
Offer a very short reply. 15.68. What is the difference between the Income share held (as % of total income) in Second 20% of population in 2007 and the Income share held (as % of total income) in Third 20% of population in 2012?
Ensure brevity in your answer.  -4.35. What is the difference between the Income share held (as % of total income) of Second 20% of population in 2007 and the Income share held (as % of total income) of Fourth 20% of population in 2012?
Provide a short and direct response. -9.86. What is the difference between the Income share held (as % of total income) in Third 20% of population in 2007 and the Income share held (as % of total income) in Fourth 20% of population in 2012?
Offer a very short reply. -5.69. What is the difference between the Income share held (as % of total income) of First 20% of population in 2008 and the Income share held (as % of total income) of Second 20% of population in 2009?
Keep it short and to the point. 25.58. What is the difference between the Income share held (as % of total income) in First 20% of population in 2008 and the Income share held (as % of total income) in Third 20% of population in 2009?
Provide a succinct answer. 21.26. What is the difference between the Income share held (as % of total income) in Second 20% of population in 2008 and the Income share held (as % of total income) in Third 20% of population in 2009?
Your answer should be compact. -4.05. What is the difference between the Income share held (as % of total income) of Second 20% of population in 2008 and the Income share held (as % of total income) of Fourth 20% of population in 2009?
Your answer should be very brief. -9.31. What is the difference between the Income share held (as % of total income) in Third 20% of population in 2008 and the Income share held (as % of total income) in Fourth 20% of population in 2009?
Your answer should be compact. -5.1. What is the difference between the Income share held (as % of total income) in First 20% of population in 2008 and the Income share held (as % of total income) in Second 20% of population in 2010?
Make the answer very short. 25.4. What is the difference between the Income share held (as % of total income) of First 20% of population in 2008 and the Income share held (as % of total income) of Third 20% of population in 2010?
Your response must be concise. 21.14. What is the difference between the Income share held (as % of total income) in First 20% of population in 2008 and the Income share held (as % of total income) in Fourth 20% of population in 2010?
Provide a short and direct response. 15.72. What is the difference between the Income share held (as % of total income) of Second 20% of population in 2008 and the Income share held (as % of total income) of Third 20% of population in 2010?
Make the answer very short. -4.17. What is the difference between the Income share held (as % of total income) in Second 20% of population in 2008 and the Income share held (as % of total income) in Fourth 20% of population in 2010?
Provide a short and direct response. -9.59. What is the difference between the Income share held (as % of total income) of Third 20% of population in 2008 and the Income share held (as % of total income) of Fourth 20% of population in 2010?
Provide a short and direct response. -5.38. What is the difference between the Income share held (as % of total income) of First 20% of population in 2008 and the Income share held (as % of total income) of Second 20% of population in 2011?
Provide a short and direct response. 25.54. What is the difference between the Income share held (as % of total income) of First 20% of population in 2008 and the Income share held (as % of total income) of Third 20% of population in 2011?
Your answer should be very brief. 21.23. What is the difference between the Income share held (as % of total income) of First 20% of population in 2008 and the Income share held (as % of total income) of Fourth 20% of population in 2011?
Offer a terse response. 15.58. What is the difference between the Income share held (as % of total income) of Second 20% of population in 2008 and the Income share held (as % of total income) of Third 20% of population in 2011?
Offer a very short reply. -4.08. What is the difference between the Income share held (as % of total income) in Second 20% of population in 2008 and the Income share held (as % of total income) in Fourth 20% of population in 2011?
Provide a short and direct response. -9.73. What is the difference between the Income share held (as % of total income) in Third 20% of population in 2008 and the Income share held (as % of total income) in Fourth 20% of population in 2011?
Provide a succinct answer. -5.52. What is the difference between the Income share held (as % of total income) in First 20% of population in 2008 and the Income share held (as % of total income) in Second 20% of population in 2012?
Provide a short and direct response. 25.32. What is the difference between the Income share held (as % of total income) in First 20% of population in 2008 and the Income share held (as % of total income) in Third 20% of population in 2012?
Offer a terse response. 21.11. What is the difference between the Income share held (as % of total income) of First 20% of population in 2008 and the Income share held (as % of total income) of Fourth 20% of population in 2012?
Give a very brief answer. 15.6. What is the difference between the Income share held (as % of total income) of Second 20% of population in 2008 and the Income share held (as % of total income) of Third 20% of population in 2012?
Your response must be concise. -4.2. What is the difference between the Income share held (as % of total income) of Second 20% of population in 2008 and the Income share held (as % of total income) of Fourth 20% of population in 2012?
Make the answer very short. -9.71. What is the difference between the Income share held (as % of total income) in First 20% of population in 2009 and the Income share held (as % of total income) in Second 20% of population in 2010?
Offer a terse response. 26.13. What is the difference between the Income share held (as % of total income) in First 20% of population in 2009 and the Income share held (as % of total income) in Third 20% of population in 2010?
Offer a very short reply. 21.87. What is the difference between the Income share held (as % of total income) in First 20% of population in 2009 and the Income share held (as % of total income) in Fourth 20% of population in 2010?
Give a very brief answer. 16.45. What is the difference between the Income share held (as % of total income) in Second 20% of population in 2009 and the Income share held (as % of total income) in Third 20% of population in 2010?
Your response must be concise. -4.44. What is the difference between the Income share held (as % of total income) of Second 20% of population in 2009 and the Income share held (as % of total income) of Fourth 20% of population in 2010?
Provide a short and direct response. -9.86. What is the difference between the Income share held (as % of total income) of Third 20% of population in 2009 and the Income share held (as % of total income) of Fourth 20% of population in 2010?
Your answer should be very brief. -5.54. What is the difference between the Income share held (as % of total income) of First 20% of population in 2009 and the Income share held (as % of total income) of Second 20% of population in 2011?
Provide a short and direct response. 26.27. What is the difference between the Income share held (as % of total income) of First 20% of population in 2009 and the Income share held (as % of total income) of Third 20% of population in 2011?
Your answer should be very brief. 21.96. What is the difference between the Income share held (as % of total income) in First 20% of population in 2009 and the Income share held (as % of total income) in Fourth 20% of population in 2011?
Your answer should be very brief. 16.31. What is the difference between the Income share held (as % of total income) in Second 20% of population in 2009 and the Income share held (as % of total income) in Third 20% of population in 2011?
Make the answer very short. -4.35. What is the difference between the Income share held (as % of total income) of Second 20% of population in 2009 and the Income share held (as % of total income) of Fourth 20% of population in 2011?
Your response must be concise. -10. What is the difference between the Income share held (as % of total income) in Third 20% of population in 2009 and the Income share held (as % of total income) in Fourth 20% of population in 2011?
Provide a short and direct response. -5.68. What is the difference between the Income share held (as % of total income) in First 20% of population in 2009 and the Income share held (as % of total income) in Second 20% of population in 2012?
Provide a short and direct response. 26.05. What is the difference between the Income share held (as % of total income) in First 20% of population in 2009 and the Income share held (as % of total income) in Third 20% of population in 2012?
Provide a short and direct response. 21.84. What is the difference between the Income share held (as % of total income) in First 20% of population in 2009 and the Income share held (as % of total income) in Fourth 20% of population in 2012?
Offer a terse response. 16.33. What is the difference between the Income share held (as % of total income) of Second 20% of population in 2009 and the Income share held (as % of total income) of Third 20% of population in 2012?
Your answer should be compact. -4.47. What is the difference between the Income share held (as % of total income) in Second 20% of population in 2009 and the Income share held (as % of total income) in Fourth 20% of population in 2012?
Offer a terse response. -9.98. What is the difference between the Income share held (as % of total income) in Third 20% of population in 2009 and the Income share held (as % of total income) in Fourth 20% of population in 2012?
Provide a succinct answer. -5.66. What is the difference between the Income share held (as % of total income) of First 20% of population in 2010 and the Income share held (as % of total income) of Second 20% of population in 2011?
Provide a succinct answer. 25.33. What is the difference between the Income share held (as % of total income) in First 20% of population in 2010 and the Income share held (as % of total income) in Third 20% of population in 2011?
Make the answer very short. 21.02. What is the difference between the Income share held (as % of total income) in First 20% of population in 2010 and the Income share held (as % of total income) in Fourth 20% of population in 2011?
Your answer should be compact. 15.37. What is the difference between the Income share held (as % of total income) of Second 20% of population in 2010 and the Income share held (as % of total income) of Third 20% of population in 2011?
Your answer should be compact. -4.17. What is the difference between the Income share held (as % of total income) in Second 20% of population in 2010 and the Income share held (as % of total income) in Fourth 20% of population in 2011?
Your answer should be very brief. -9.82. What is the difference between the Income share held (as % of total income) in Third 20% of population in 2010 and the Income share held (as % of total income) in Fourth 20% of population in 2011?
Your response must be concise. -5.56. What is the difference between the Income share held (as % of total income) of First 20% of population in 2010 and the Income share held (as % of total income) of Second 20% of population in 2012?
Your answer should be very brief. 25.11. What is the difference between the Income share held (as % of total income) of First 20% of population in 2010 and the Income share held (as % of total income) of Third 20% of population in 2012?
Offer a very short reply. 20.9. What is the difference between the Income share held (as % of total income) in First 20% of population in 2010 and the Income share held (as % of total income) in Fourth 20% of population in 2012?
Provide a succinct answer. 15.39. What is the difference between the Income share held (as % of total income) of Second 20% of population in 2010 and the Income share held (as % of total income) of Third 20% of population in 2012?
Make the answer very short. -4.29. What is the difference between the Income share held (as % of total income) of Third 20% of population in 2010 and the Income share held (as % of total income) of Fourth 20% of population in 2012?
Offer a very short reply. -5.54. What is the difference between the Income share held (as % of total income) in First 20% of population in 2011 and the Income share held (as % of total income) in Second 20% of population in 2012?
Make the answer very short. 25.39. What is the difference between the Income share held (as % of total income) in First 20% of population in 2011 and the Income share held (as % of total income) in Third 20% of population in 2012?
Your response must be concise. 21.18. What is the difference between the Income share held (as % of total income) in First 20% of population in 2011 and the Income share held (as % of total income) in Fourth 20% of population in 2012?
Keep it short and to the point. 15.67. What is the difference between the Income share held (as % of total income) in Second 20% of population in 2011 and the Income share held (as % of total income) in Third 20% of population in 2012?
Make the answer very short. -4.43. What is the difference between the Income share held (as % of total income) of Second 20% of population in 2011 and the Income share held (as % of total income) of Fourth 20% of population in 2012?
Give a very brief answer. -9.94. What is the difference between the Income share held (as % of total income) in Third 20% of population in 2011 and the Income share held (as % of total income) in Fourth 20% of population in 2012?
Your answer should be compact. -5.63. What is the average Income share held (as % of total income) of First 20% of population per year?
Your response must be concise. 38.5. What is the average Income share held (as % of total income) of Second 20% of population per year?
Your answer should be compact. 13.23. What is the average Income share held (as % of total income) in Third 20% of population per year?
Provide a short and direct response. 17.38. What is the average Income share held (as % of total income) of Fourth 20% of population per year?
Your answer should be compact. 22.76. In the year 2004, what is the difference between the Income share held (as % of total income) of First 20% of population and Income share held (as % of total income) of Second 20% of population?
Make the answer very short. 25.3. In the year 2004, what is the difference between the Income share held (as % of total income) in First 20% of population and Income share held (as % of total income) in Third 20% of population?
Your answer should be very brief. 21.31. In the year 2004, what is the difference between the Income share held (as % of total income) of First 20% of population and Income share held (as % of total income) of Fourth 20% of population?
Offer a terse response. 16.08. In the year 2004, what is the difference between the Income share held (as % of total income) in Second 20% of population and Income share held (as % of total income) in Third 20% of population?
Ensure brevity in your answer.  -3.99. In the year 2004, what is the difference between the Income share held (as % of total income) of Second 20% of population and Income share held (as % of total income) of Fourth 20% of population?
Make the answer very short. -9.22. In the year 2004, what is the difference between the Income share held (as % of total income) of Third 20% of population and Income share held (as % of total income) of Fourth 20% of population?
Offer a terse response. -5.23. In the year 2005, what is the difference between the Income share held (as % of total income) of First 20% of population and Income share held (as % of total income) of Second 20% of population?
Ensure brevity in your answer.  24.1. In the year 2005, what is the difference between the Income share held (as % of total income) of First 20% of population and Income share held (as % of total income) of Third 20% of population?
Make the answer very short. 20.06. In the year 2005, what is the difference between the Income share held (as % of total income) of First 20% of population and Income share held (as % of total income) of Fourth 20% of population?
Offer a terse response. 14.76. In the year 2005, what is the difference between the Income share held (as % of total income) of Second 20% of population and Income share held (as % of total income) of Third 20% of population?
Make the answer very short. -4.04. In the year 2005, what is the difference between the Income share held (as % of total income) in Second 20% of population and Income share held (as % of total income) in Fourth 20% of population?
Provide a succinct answer. -9.34. In the year 2006, what is the difference between the Income share held (as % of total income) in First 20% of population and Income share held (as % of total income) in Second 20% of population?
Offer a terse response. 24.96. In the year 2006, what is the difference between the Income share held (as % of total income) in First 20% of population and Income share held (as % of total income) in Third 20% of population?
Provide a succinct answer. 21.09. In the year 2006, what is the difference between the Income share held (as % of total income) of First 20% of population and Income share held (as % of total income) of Fourth 20% of population?
Your answer should be very brief. 15.71. In the year 2006, what is the difference between the Income share held (as % of total income) of Second 20% of population and Income share held (as % of total income) of Third 20% of population?
Provide a succinct answer. -3.87. In the year 2006, what is the difference between the Income share held (as % of total income) of Second 20% of population and Income share held (as % of total income) of Fourth 20% of population?
Offer a terse response. -9.25. In the year 2006, what is the difference between the Income share held (as % of total income) in Third 20% of population and Income share held (as % of total income) in Fourth 20% of population?
Ensure brevity in your answer.  -5.38. In the year 2007, what is the difference between the Income share held (as % of total income) in First 20% of population and Income share held (as % of total income) in Second 20% of population?
Keep it short and to the point. 25.54. In the year 2007, what is the difference between the Income share held (as % of total income) in First 20% of population and Income share held (as % of total income) in Third 20% of population?
Make the answer very short. 21.37. In the year 2007, what is the difference between the Income share held (as % of total income) in First 20% of population and Income share held (as % of total income) in Fourth 20% of population?
Give a very brief answer. 15.83. In the year 2007, what is the difference between the Income share held (as % of total income) in Second 20% of population and Income share held (as % of total income) in Third 20% of population?
Your answer should be very brief. -4.17. In the year 2007, what is the difference between the Income share held (as % of total income) in Second 20% of population and Income share held (as % of total income) in Fourth 20% of population?
Your answer should be compact. -9.71. In the year 2007, what is the difference between the Income share held (as % of total income) of Third 20% of population and Income share held (as % of total income) of Fourth 20% of population?
Provide a short and direct response. -5.54. In the year 2008, what is the difference between the Income share held (as % of total income) of First 20% of population and Income share held (as % of total income) of Second 20% of population?
Your answer should be very brief. 25.31. In the year 2008, what is the difference between the Income share held (as % of total income) in First 20% of population and Income share held (as % of total income) in Third 20% of population?
Keep it short and to the point. 21.1. In the year 2008, what is the difference between the Income share held (as % of total income) of First 20% of population and Income share held (as % of total income) of Fourth 20% of population?
Provide a succinct answer. 16.02. In the year 2008, what is the difference between the Income share held (as % of total income) in Second 20% of population and Income share held (as % of total income) in Third 20% of population?
Offer a very short reply. -4.21. In the year 2008, what is the difference between the Income share held (as % of total income) in Second 20% of population and Income share held (as % of total income) in Fourth 20% of population?
Your answer should be very brief. -9.29. In the year 2008, what is the difference between the Income share held (as % of total income) in Third 20% of population and Income share held (as % of total income) in Fourth 20% of population?
Make the answer very short. -5.08. In the year 2009, what is the difference between the Income share held (as % of total income) in First 20% of population and Income share held (as % of total income) in Second 20% of population?
Offer a terse response. 26.31. In the year 2009, what is the difference between the Income share held (as % of total income) in First 20% of population and Income share held (as % of total income) in Third 20% of population?
Make the answer very short. 21.99. In the year 2009, what is the difference between the Income share held (as % of total income) of First 20% of population and Income share held (as % of total income) of Fourth 20% of population?
Offer a terse response. 16.73. In the year 2009, what is the difference between the Income share held (as % of total income) of Second 20% of population and Income share held (as % of total income) of Third 20% of population?
Your answer should be very brief. -4.32. In the year 2009, what is the difference between the Income share held (as % of total income) of Second 20% of population and Income share held (as % of total income) of Fourth 20% of population?
Keep it short and to the point. -9.58. In the year 2009, what is the difference between the Income share held (as % of total income) of Third 20% of population and Income share held (as % of total income) of Fourth 20% of population?
Your answer should be very brief. -5.26. In the year 2010, what is the difference between the Income share held (as % of total income) in First 20% of population and Income share held (as % of total income) in Second 20% of population?
Make the answer very short. 25.19. In the year 2010, what is the difference between the Income share held (as % of total income) of First 20% of population and Income share held (as % of total income) of Third 20% of population?
Ensure brevity in your answer.  20.93. In the year 2010, what is the difference between the Income share held (as % of total income) in First 20% of population and Income share held (as % of total income) in Fourth 20% of population?
Make the answer very short. 15.51. In the year 2010, what is the difference between the Income share held (as % of total income) in Second 20% of population and Income share held (as % of total income) in Third 20% of population?
Provide a succinct answer. -4.26. In the year 2010, what is the difference between the Income share held (as % of total income) in Second 20% of population and Income share held (as % of total income) in Fourth 20% of population?
Provide a short and direct response. -9.68. In the year 2010, what is the difference between the Income share held (as % of total income) in Third 20% of population and Income share held (as % of total income) in Fourth 20% of population?
Your answer should be very brief. -5.42. In the year 2011, what is the difference between the Income share held (as % of total income) of First 20% of population and Income share held (as % of total income) of Second 20% of population?
Give a very brief answer. 25.61. In the year 2011, what is the difference between the Income share held (as % of total income) of First 20% of population and Income share held (as % of total income) of Third 20% of population?
Keep it short and to the point. 21.3. In the year 2011, what is the difference between the Income share held (as % of total income) in First 20% of population and Income share held (as % of total income) in Fourth 20% of population?
Provide a short and direct response. 15.65. In the year 2011, what is the difference between the Income share held (as % of total income) of Second 20% of population and Income share held (as % of total income) of Third 20% of population?
Your response must be concise. -4.31. In the year 2011, what is the difference between the Income share held (as % of total income) in Second 20% of population and Income share held (as % of total income) in Fourth 20% of population?
Provide a short and direct response. -9.96. In the year 2011, what is the difference between the Income share held (as % of total income) in Third 20% of population and Income share held (as % of total income) in Fourth 20% of population?
Your answer should be compact. -5.65. In the year 2012, what is the difference between the Income share held (as % of total income) of First 20% of population and Income share held (as % of total income) of Second 20% of population?
Offer a terse response. 25.12. In the year 2012, what is the difference between the Income share held (as % of total income) in First 20% of population and Income share held (as % of total income) in Third 20% of population?
Your answer should be compact. 20.91. In the year 2012, what is the difference between the Income share held (as % of total income) in First 20% of population and Income share held (as % of total income) in Fourth 20% of population?
Your answer should be very brief. 15.4. In the year 2012, what is the difference between the Income share held (as % of total income) in Second 20% of population and Income share held (as % of total income) in Third 20% of population?
Your answer should be compact. -4.21. In the year 2012, what is the difference between the Income share held (as % of total income) of Second 20% of population and Income share held (as % of total income) of Fourth 20% of population?
Your answer should be very brief. -9.72. In the year 2012, what is the difference between the Income share held (as % of total income) of Third 20% of population and Income share held (as % of total income) of Fourth 20% of population?
Provide a short and direct response. -5.51. What is the ratio of the Income share held (as % of total income) in First 20% of population in 2004 to that in 2005?
Your answer should be very brief. 1.03. What is the ratio of the Income share held (as % of total income) in Second 20% of population in 2004 to that in 2005?
Your answer should be very brief. 0.99. What is the ratio of the Income share held (as % of total income) in Third 20% of population in 2004 to that in 2005?
Make the answer very short. 0.99. What is the ratio of the Income share held (as % of total income) in Fourth 20% of population in 2004 to that in 2005?
Give a very brief answer. 0.99. What is the ratio of the Income share held (as % of total income) in First 20% of population in 2004 to that in 2006?
Your answer should be very brief. 1.01. What is the ratio of the Income share held (as % of total income) in Third 20% of population in 2004 to that in 2006?
Offer a terse response. 1. What is the ratio of the Income share held (as % of total income) of Fourth 20% of population in 2004 to that in 2006?
Give a very brief answer. 1. What is the ratio of the Income share held (as % of total income) in First 20% of population in 2004 to that in 2007?
Give a very brief answer. 1. What is the ratio of the Income share held (as % of total income) in Second 20% of population in 2004 to that in 2007?
Provide a succinct answer. 1.01. What is the ratio of the Income share held (as % of total income) in Third 20% of population in 2004 to that in 2007?
Your answer should be compact. 1. What is the ratio of the Income share held (as % of total income) in Fourth 20% of population in 2004 to that in 2007?
Your answer should be very brief. 0.98. What is the ratio of the Income share held (as % of total income) in Third 20% of population in 2004 to that in 2008?
Make the answer very short. 0.98. What is the ratio of the Income share held (as % of total income) in Fourth 20% of population in 2004 to that in 2008?
Your answer should be compact. 0.99. What is the ratio of the Income share held (as % of total income) of First 20% of population in 2004 to that in 2009?
Provide a short and direct response. 0.98. What is the ratio of the Income share held (as % of total income) of Second 20% of population in 2004 to that in 2009?
Provide a succinct answer. 1.02. What is the ratio of the Income share held (as % of total income) in Third 20% of population in 2004 to that in 2009?
Provide a short and direct response. 0.99. What is the ratio of the Income share held (as % of total income) of Fourth 20% of population in 2004 to that in 2009?
Your answer should be compact. 0.99. What is the ratio of the Income share held (as % of total income) in First 20% of population in 2004 to that in 2010?
Offer a very short reply. 1. What is the ratio of the Income share held (as % of total income) in Fourth 20% of population in 2004 to that in 2010?
Keep it short and to the point. 0.98. What is the ratio of the Income share held (as % of total income) of First 20% of population in 2004 to that in 2011?
Offer a very short reply. 1. What is the ratio of the Income share held (as % of total income) in Second 20% of population in 2004 to that in 2011?
Give a very brief answer. 1.01. What is the ratio of the Income share held (as % of total income) in Fourth 20% of population in 2004 to that in 2011?
Make the answer very short. 0.98. What is the ratio of the Income share held (as % of total income) of Third 20% of population in 2004 to that in 2012?
Your response must be concise. 0.99. What is the ratio of the Income share held (as % of total income) in Fourth 20% of population in 2004 to that in 2012?
Give a very brief answer. 0.98. What is the ratio of the Income share held (as % of total income) of First 20% of population in 2005 to that in 2006?
Your answer should be compact. 0.98. What is the ratio of the Income share held (as % of total income) in Second 20% of population in 2005 to that in 2006?
Your answer should be very brief. 1.01. What is the ratio of the Income share held (as % of total income) in Third 20% of population in 2005 to that in 2006?
Your answer should be very brief. 1.02. What is the ratio of the Income share held (as % of total income) of Fourth 20% of population in 2005 to that in 2006?
Your answer should be very brief. 1.01. What is the ratio of the Income share held (as % of total income) of First 20% of population in 2005 to that in 2007?
Keep it short and to the point. 0.97. What is the ratio of the Income share held (as % of total income) in Second 20% of population in 2005 to that in 2007?
Your response must be concise. 1.02. What is the ratio of the Income share held (as % of total income) in Third 20% of population in 2005 to that in 2007?
Offer a terse response. 1.01. What is the ratio of the Income share held (as % of total income) of Fourth 20% of population in 2005 to that in 2007?
Offer a very short reply. 1. What is the ratio of the Income share held (as % of total income) of First 20% of population in 2005 to that in 2008?
Provide a succinct answer. 0.97. What is the ratio of the Income share held (as % of total income) of Second 20% of population in 2005 to that in 2008?
Ensure brevity in your answer.  1.01. What is the ratio of the Income share held (as % of total income) in Third 20% of population in 2005 to that in 2008?
Provide a short and direct response. 1. What is the ratio of the Income share held (as % of total income) of Fourth 20% of population in 2005 to that in 2008?
Your response must be concise. 1.01. What is the ratio of the Income share held (as % of total income) in First 20% of population in 2005 to that in 2009?
Provide a short and direct response. 0.95. What is the ratio of the Income share held (as % of total income) in Second 20% of population in 2005 to that in 2009?
Your response must be concise. 1.03. What is the ratio of the Income share held (as % of total income) of Third 20% of population in 2005 to that in 2009?
Give a very brief answer. 1.01. What is the ratio of the Income share held (as % of total income) in Fourth 20% of population in 2005 to that in 2009?
Ensure brevity in your answer.  1.01. What is the ratio of the Income share held (as % of total income) of First 20% of population in 2005 to that in 2010?
Your response must be concise. 0.98. What is the ratio of the Income share held (as % of total income) in Second 20% of population in 2005 to that in 2010?
Offer a very short reply. 1.02. What is the ratio of the Income share held (as % of total income) in Third 20% of population in 2005 to that in 2010?
Offer a very short reply. 1. What is the ratio of the Income share held (as % of total income) of Fourth 20% of population in 2005 to that in 2010?
Your answer should be very brief. 1. What is the ratio of the Income share held (as % of total income) of First 20% of population in 2005 to that in 2011?
Make the answer very short. 0.97. What is the ratio of the Income share held (as % of total income) in Second 20% of population in 2005 to that in 2011?
Provide a short and direct response. 1.03. What is the ratio of the Income share held (as % of total income) of Fourth 20% of population in 2005 to that in 2011?
Your response must be concise. 0.99. What is the ratio of the Income share held (as % of total income) of First 20% of population in 2005 to that in 2012?
Make the answer very short. 0.98. What is the ratio of the Income share held (as % of total income) of Second 20% of population in 2005 to that in 2012?
Keep it short and to the point. 1.01. What is the ratio of the Income share held (as % of total income) of Third 20% of population in 2005 to that in 2012?
Provide a succinct answer. 1. What is the ratio of the Income share held (as % of total income) of First 20% of population in 2006 to that in 2007?
Give a very brief answer. 0.99. What is the ratio of the Income share held (as % of total income) in Second 20% of population in 2006 to that in 2007?
Ensure brevity in your answer.  1.01. What is the ratio of the Income share held (as % of total income) in First 20% of population in 2006 to that in 2008?
Offer a terse response. 0.99. What is the ratio of the Income share held (as % of total income) in Second 20% of population in 2006 to that in 2008?
Your answer should be very brief. 1. What is the ratio of the Income share held (as % of total income) in Third 20% of population in 2006 to that in 2008?
Ensure brevity in your answer.  0.98. What is the ratio of the Income share held (as % of total income) of First 20% of population in 2006 to that in 2009?
Make the answer very short. 0.97. What is the ratio of the Income share held (as % of total income) in Fourth 20% of population in 2006 to that in 2009?
Provide a succinct answer. 1. What is the ratio of the Income share held (as % of total income) in First 20% of population in 2006 to that in 2010?
Provide a short and direct response. 1. What is the ratio of the Income share held (as % of total income) in Second 20% of population in 2006 to that in 2010?
Your response must be concise. 1.01. What is the ratio of the Income share held (as % of total income) in Third 20% of population in 2006 to that in 2010?
Your answer should be very brief. 0.98. What is the ratio of the Income share held (as % of total income) in Fourth 20% of population in 2006 to that in 2010?
Your response must be concise. 0.99. What is the ratio of the Income share held (as % of total income) of Second 20% of population in 2006 to that in 2011?
Provide a short and direct response. 1.02. What is the ratio of the Income share held (as % of total income) of Third 20% of population in 2006 to that in 2011?
Your answer should be compact. 0.99. What is the ratio of the Income share held (as % of total income) in Fourth 20% of population in 2006 to that in 2011?
Ensure brevity in your answer.  0.98. What is the ratio of the Income share held (as % of total income) in Third 20% of population in 2006 to that in 2012?
Ensure brevity in your answer.  0.98. What is the ratio of the Income share held (as % of total income) of Fourth 20% of population in 2006 to that in 2012?
Offer a terse response. 0.98. What is the ratio of the Income share held (as % of total income) in First 20% of population in 2007 to that in 2008?
Keep it short and to the point. 1. What is the ratio of the Income share held (as % of total income) of Second 20% of population in 2007 to that in 2008?
Your answer should be compact. 0.99. What is the ratio of the Income share held (as % of total income) in Fourth 20% of population in 2007 to that in 2008?
Your answer should be compact. 1.01. What is the ratio of the Income share held (as % of total income) of First 20% of population in 2007 to that in 2009?
Keep it short and to the point. 0.98. What is the ratio of the Income share held (as % of total income) in Second 20% of population in 2007 to that in 2009?
Ensure brevity in your answer.  1.01. What is the ratio of the Income share held (as % of total income) in Fourth 20% of population in 2007 to that in 2009?
Ensure brevity in your answer.  1.01. What is the ratio of the Income share held (as % of total income) of First 20% of population in 2007 to that in 2010?
Keep it short and to the point. 1.01. What is the ratio of the Income share held (as % of total income) in Second 20% of population in 2007 to that in 2010?
Give a very brief answer. 1. What is the ratio of the Income share held (as % of total income) of Third 20% of population in 2007 to that in 2010?
Provide a succinct answer. 0.99. What is the ratio of the Income share held (as % of total income) in First 20% of population in 2007 to that in 2011?
Ensure brevity in your answer.  1. What is the ratio of the Income share held (as % of total income) in Second 20% of population in 2007 to that in 2011?
Provide a succinct answer. 1.01. What is the ratio of the Income share held (as % of total income) of Third 20% of population in 2007 to that in 2011?
Ensure brevity in your answer.  1. What is the ratio of the Income share held (as % of total income) in Fourth 20% of population in 2007 to that in 2011?
Ensure brevity in your answer.  0.99. What is the ratio of the Income share held (as % of total income) in First 20% of population in 2007 to that in 2012?
Offer a very short reply. 1.01. What is the ratio of the Income share held (as % of total income) of Second 20% of population in 2007 to that in 2012?
Your response must be concise. 0.99. What is the ratio of the Income share held (as % of total income) in Fourth 20% of population in 2007 to that in 2012?
Ensure brevity in your answer.  0.99. What is the ratio of the Income share held (as % of total income) in First 20% of population in 2008 to that in 2009?
Ensure brevity in your answer.  0.98. What is the ratio of the Income share held (as % of total income) of Second 20% of population in 2008 to that in 2009?
Make the answer very short. 1.02. What is the ratio of the Income share held (as % of total income) of Third 20% of population in 2008 to that in 2009?
Provide a succinct answer. 1.01. What is the ratio of the Income share held (as % of total income) of First 20% of population in 2008 to that in 2010?
Your answer should be compact. 1.01. What is the ratio of the Income share held (as % of total income) in Second 20% of population in 2008 to that in 2010?
Offer a very short reply. 1.01. What is the ratio of the Income share held (as % of total income) in Fourth 20% of population in 2008 to that in 2010?
Provide a short and direct response. 0.99. What is the ratio of the Income share held (as % of total income) in First 20% of population in 2008 to that in 2011?
Offer a very short reply. 1. What is the ratio of the Income share held (as % of total income) in Second 20% of population in 2008 to that in 2011?
Keep it short and to the point. 1.02. What is the ratio of the Income share held (as % of total income) in Third 20% of population in 2008 to that in 2011?
Provide a succinct answer. 1.01. What is the ratio of the Income share held (as % of total income) of Fourth 20% of population in 2008 to that in 2011?
Your response must be concise. 0.98. What is the ratio of the Income share held (as % of total income) of Second 20% of population in 2008 to that in 2012?
Your response must be concise. 1. What is the ratio of the Income share held (as % of total income) in Fourth 20% of population in 2008 to that in 2012?
Give a very brief answer. 0.98. What is the ratio of the Income share held (as % of total income) in First 20% of population in 2009 to that in 2010?
Keep it short and to the point. 1.02. What is the ratio of the Income share held (as % of total income) of Second 20% of population in 2009 to that in 2010?
Your answer should be very brief. 0.99. What is the ratio of the Income share held (as % of total income) of First 20% of population in 2009 to that in 2011?
Offer a very short reply. 1.02. What is the ratio of the Income share held (as % of total income) in Third 20% of population in 2009 to that in 2011?
Offer a very short reply. 1. What is the ratio of the Income share held (as % of total income) in Fourth 20% of population in 2009 to that in 2011?
Your answer should be compact. 0.98. What is the ratio of the Income share held (as % of total income) in First 20% of population in 2009 to that in 2012?
Provide a short and direct response. 1.02. What is the ratio of the Income share held (as % of total income) of Second 20% of population in 2009 to that in 2012?
Keep it short and to the point. 0.98. What is the ratio of the Income share held (as % of total income) of Fourth 20% of population in 2009 to that in 2012?
Provide a short and direct response. 0.98. What is the ratio of the Income share held (as % of total income) of Second 20% of population in 2010 to that in 2011?
Keep it short and to the point. 1.01. What is the ratio of the Income share held (as % of total income) of Third 20% of population in 2010 to that in 2011?
Make the answer very short. 1.01. What is the ratio of the Income share held (as % of total income) of Fourth 20% of population in 2010 to that in 2011?
Provide a succinct answer. 0.99. What is the ratio of the Income share held (as % of total income) in First 20% of population in 2010 to that in 2012?
Make the answer very short. 1. What is the ratio of the Income share held (as % of total income) in Second 20% of population in 2010 to that in 2012?
Offer a very short reply. 0.99. What is the ratio of the Income share held (as % of total income) of Third 20% of population in 2010 to that in 2012?
Your answer should be very brief. 1. What is the ratio of the Income share held (as % of total income) in Fourth 20% of population in 2010 to that in 2012?
Provide a short and direct response. 0.99. What is the ratio of the Income share held (as % of total income) of Second 20% of population in 2011 to that in 2012?
Offer a terse response. 0.98. What is the difference between the highest and the second highest Income share held (as % of total income) of First 20% of population?
Make the answer very short. 0.65. What is the difference between the highest and the second highest Income share held (as % of total income) in Second 20% of population?
Provide a succinct answer. 0.11. What is the difference between the highest and the second highest Income share held (as % of total income) in Third 20% of population?
Give a very brief answer. 0.01. What is the difference between the highest and the second highest Income share held (as % of total income) of Fourth 20% of population?
Make the answer very short. 0.02. What is the difference between the highest and the lowest Income share held (as % of total income) in First 20% of population?
Make the answer very short. 1.8. What is the difference between the highest and the lowest Income share held (as % of total income) in Second 20% of population?
Keep it short and to the point. 0.41. What is the difference between the highest and the lowest Income share held (as % of total income) in Third 20% of population?
Provide a succinct answer. 0.31. What is the difference between the highest and the lowest Income share held (as % of total income) of Fourth 20% of population?
Your response must be concise. 0.56. 